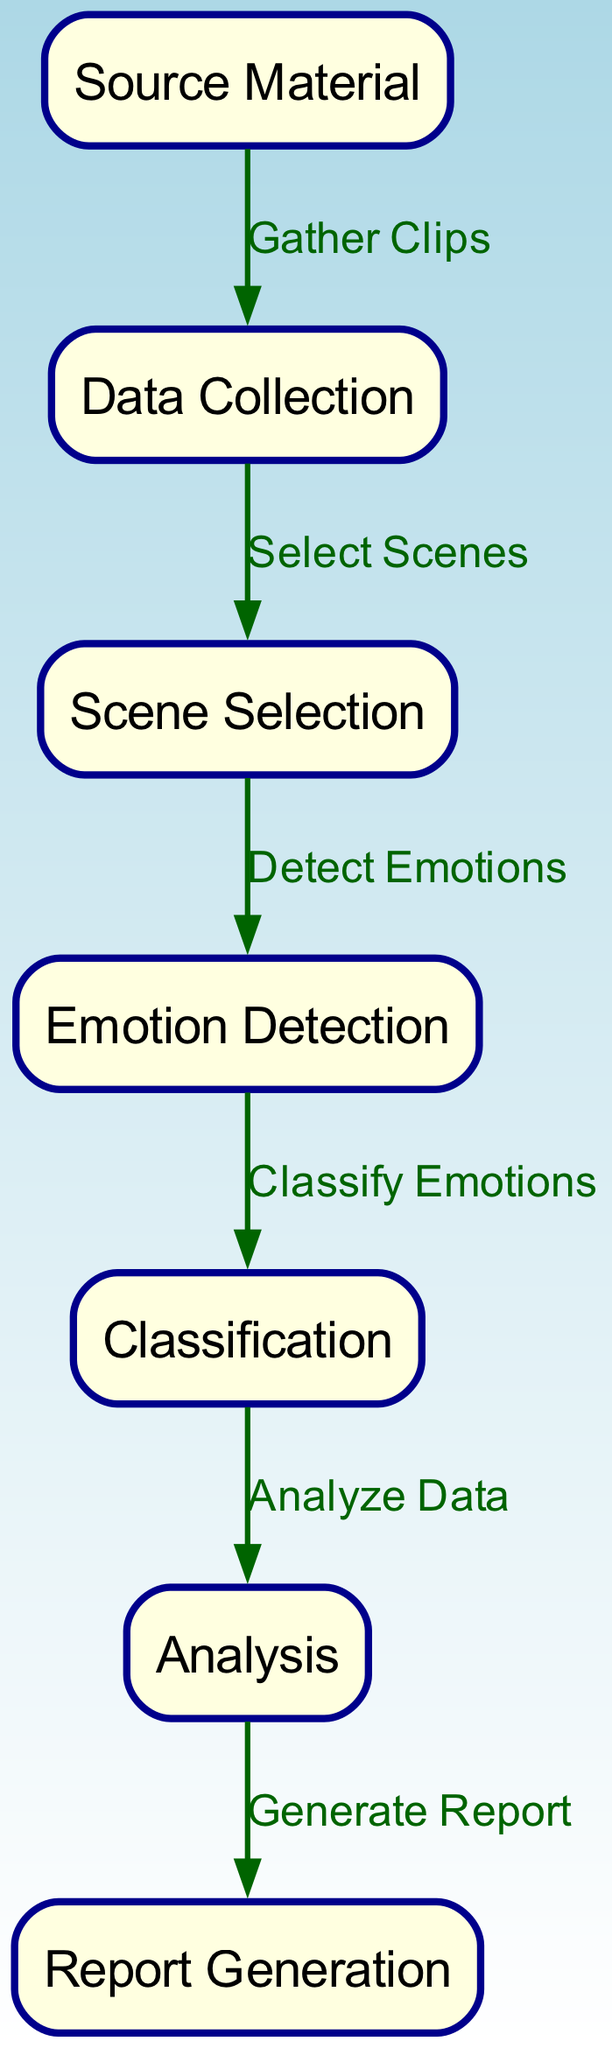What is the first step in the character emotion analysis process? The first step is represented by the node labeled "Source Material," indicating the starting point for gathering clips.
Answer: Source Material How many nodes are present in the diagram? The diagram contains 7 nodes, each representing a specific step in the character emotion analysis process.
Answer: 7 What follows the "Data Collection" node? The node that follows "Data Collection" is labeled "Scene Selection," indicating the next step taken after gathering clips.
Answer: Scene Selection What is the relationship between "Emotion Detection" and "Classification"? "Emotion Detection" leads to "Classification," meaning that once emotions are detected, they are classified in the next step.
Answer: Classify Emotions What is the last step in the character emotion analysis process? The last step is "Report Generation," which signifies the completion of the analysis process by generating a report.
Answer: Report Generation In how many steps does data transition from "scene_selection" to "report_generation"? Data transitions through 5 steps, moving from "scene_selection" to "report_generation" by going through "emotion_detection," "classification," and "analysis."
Answer: 5 Which node comes directly after "Classification"? The node that directly follows "Classification" is "Analysis," indicating the processing of classified emotion data.
Answer: Analysis What type of relationship does the arrow labeled "Select Scenes" represent in the diagram? The arrow labeled "Select Scenes" indicates the action of selecting scenes after data has been collected, representing a flow from data collection to scene selection.
Answer: Select Scenes 